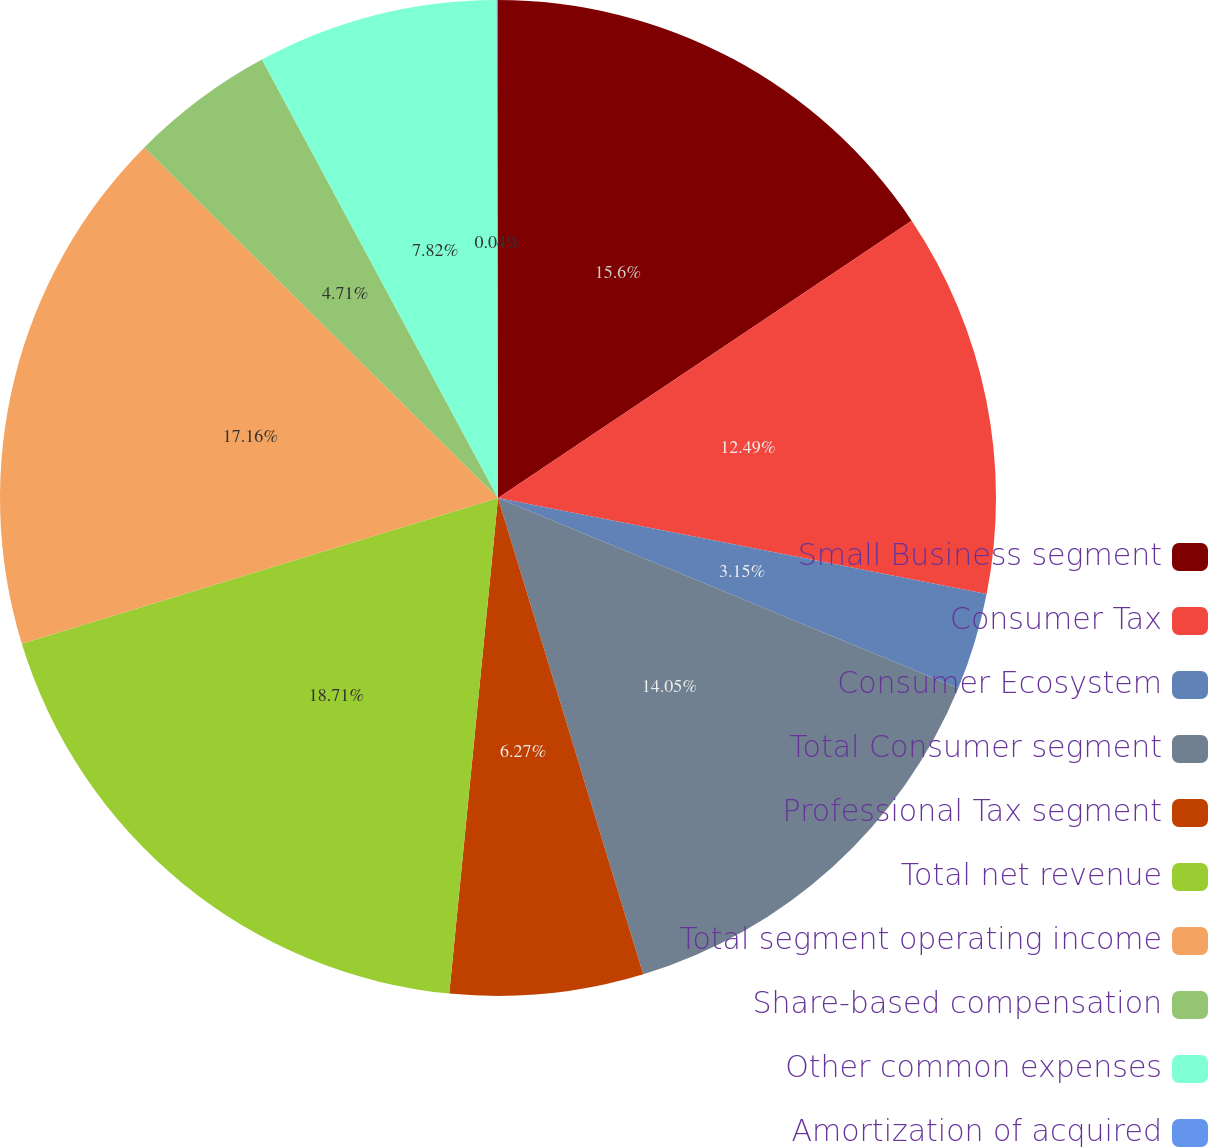Convert chart to OTSL. <chart><loc_0><loc_0><loc_500><loc_500><pie_chart><fcel>Small Business segment<fcel>Consumer Tax<fcel>Consumer Ecosystem<fcel>Total Consumer segment<fcel>Professional Tax segment<fcel>Total net revenue<fcel>Total segment operating income<fcel>Share-based compensation<fcel>Other common expenses<fcel>Amortization of acquired<nl><fcel>15.6%<fcel>12.49%<fcel>3.15%<fcel>14.05%<fcel>6.27%<fcel>18.71%<fcel>17.16%<fcel>4.71%<fcel>7.82%<fcel>0.04%<nl></chart> 